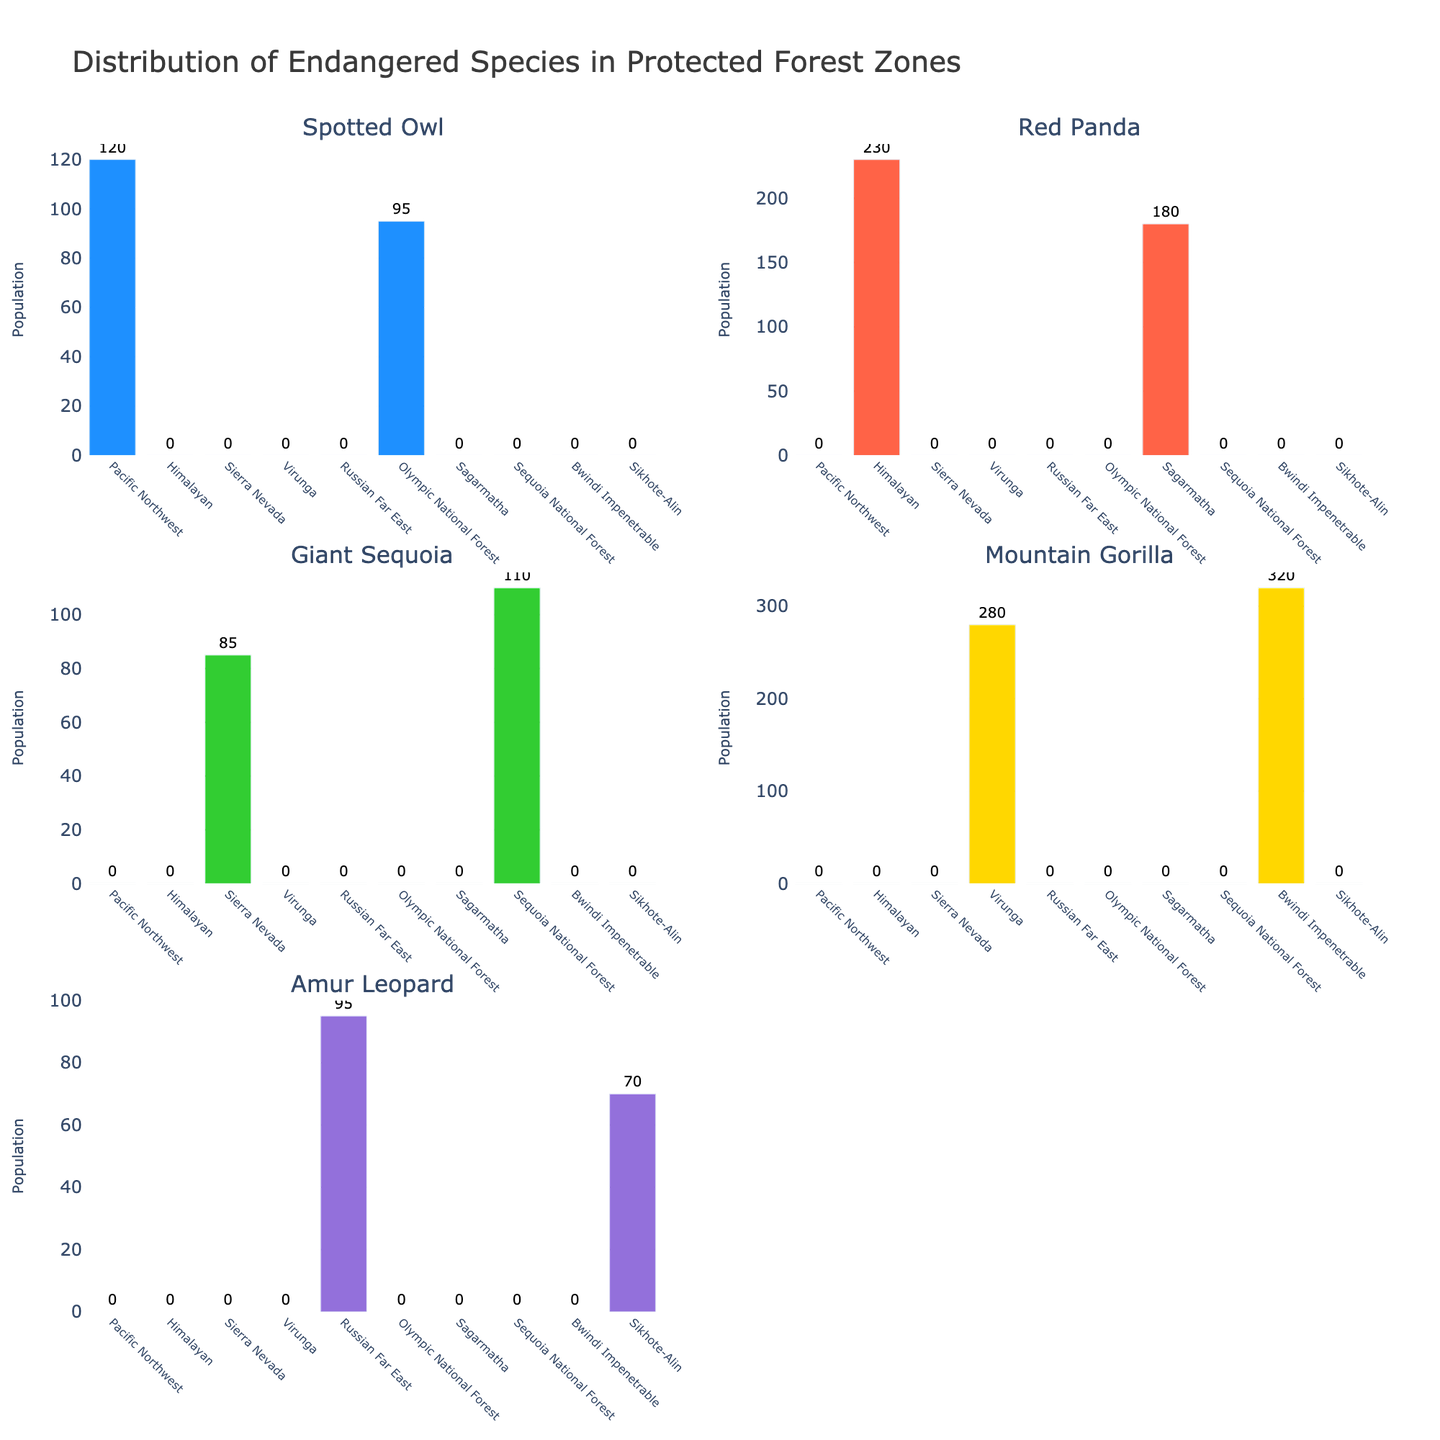What is the title of the figure? The title of the figure is displayed at the top and summarizes the figure's content.
Answer: Distribution of Endangered Species in Protected Forest Zones How many forest zones are shown in the figure? Count the number of different forest zones listed on the x-axis across all subplots.
Answer: 10 Which species has the highest population in any single forest zone? Look at all subplots and identify the species with the highest bar. The tallest bar represents the highest population.
Answer: Mountain Gorilla What is the total population of the Spotted Owl across all forest zones? Sum the population of the Spotted Owl from all bars in the Spotted Owl subplot. The values are 120 (Pacific Northwest) + 95 (Olympic National Forest).
Answer: 215 Which forest zone has populations of two different endangered species? Look across all subplots and identify the zone(s) appearing in two different subplots.
Answer: None Which species is found in the Russian Far East zone? Locate the Russian Far East on the x-axis of each subplot and identify the species with a non-zero bar.
Answer: Amur Leopard Compare the population of Red Pandas in the Himalayan zone to the population in the Sagarmatha zone. Which zone has a higher population? Look at the Red Panda subplot and compare the heights of the bars corresponding to the Himalayan and Sagarmatha zones.
Answer: Himalayan What is the sum of the populations of the Giant Sequoia in the Sierra Nevada and Sequoia National Forest zones? Add the values from the Giant Sequoia subplot for Sierra Nevada and Sequoia National Forest zones. The values are 85 (Sierra Nevada) + 110 (Sequoia National Forest).
Answer: 195 Which species is represented by the purple color in the figure? Identify the species corresponding to the purple bars in the subplots.
Answer: Amur Leopard Between Virunga and Bwindi Impenetrable zones, which has a higher population of Mountain Gorillas? Compare the heights of the bars for the Mountain Gorilla subplot between Virunga and Bwindi Impenetrable zones.
Answer: Bwindi Impenetrable 